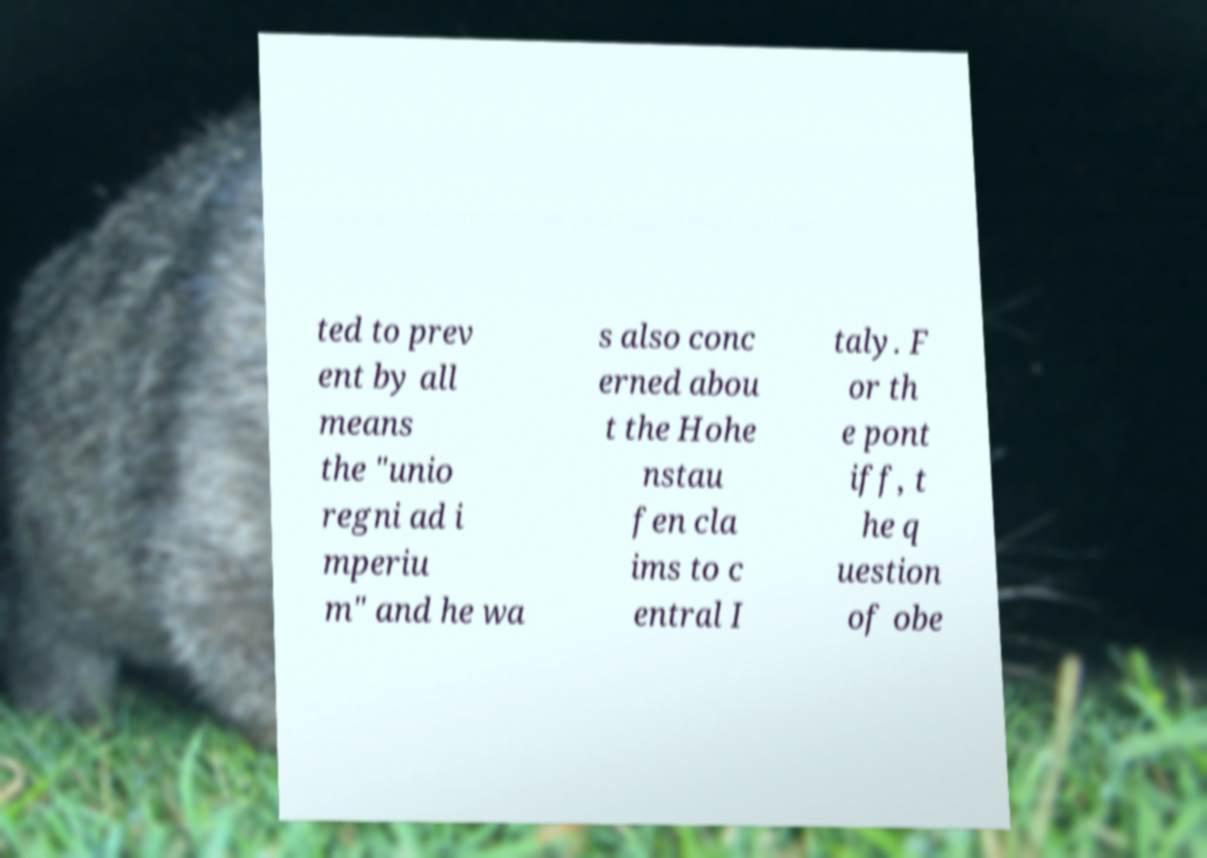Please read and relay the text visible in this image. What does it say? ted to prev ent by all means the "unio regni ad i mperiu m" and he wa s also conc erned abou t the Hohe nstau fen cla ims to c entral I taly. F or th e pont iff, t he q uestion of obe 